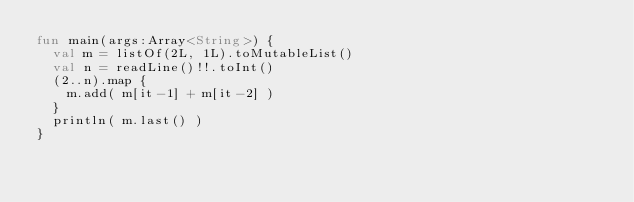Convert code to text. <code><loc_0><loc_0><loc_500><loc_500><_Kotlin_>fun main(args:Array<String>) { 
  val m = listOf(2L, 1L).toMutableList() 
  val n = readLine()!!.toInt() 
  (2..n).map { 
    m.add( m[it-1] + m[it-2] )
  }
  println( m.last() )
}</code> 